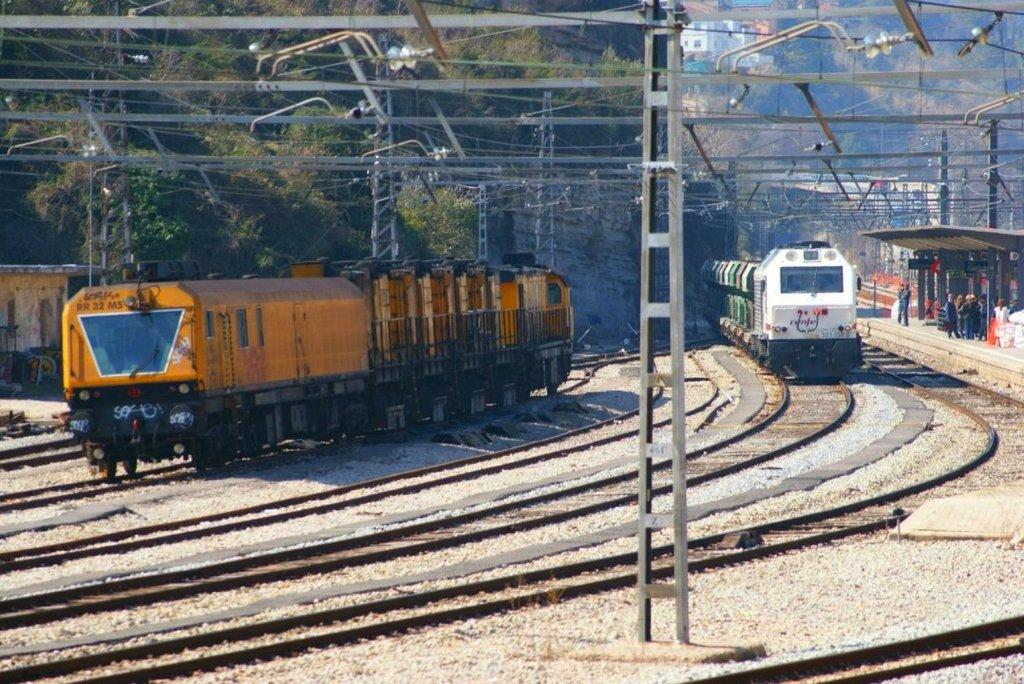What type of vehicles are on tracks in the image? Trains are on tracks in the image. What are the rods used for in the image? The purpose of the rods is not explicitly mentioned, but they may be part of the train or railway infrastructure. Can you describe the people in the image? There are people present in the image, but their specific actions or roles are not clear from the provided facts. What type of structure is present in the image? An open-shed is present in the image. What other structures can be seen in the image? There are buildings in the image. What type of natural elements are visible in the image? Trees are visible in the image. What type of linen is being used to create the song in the image? There is no mention of linen or a song in the image; it features trains on tracks, rods, people, an open-shed, buildings, and trees. Can you describe the color of the blood visible in the image? There is no blood present in the image; it features trains on tracks, rods, people, an open-shed, buildings, and trees. 